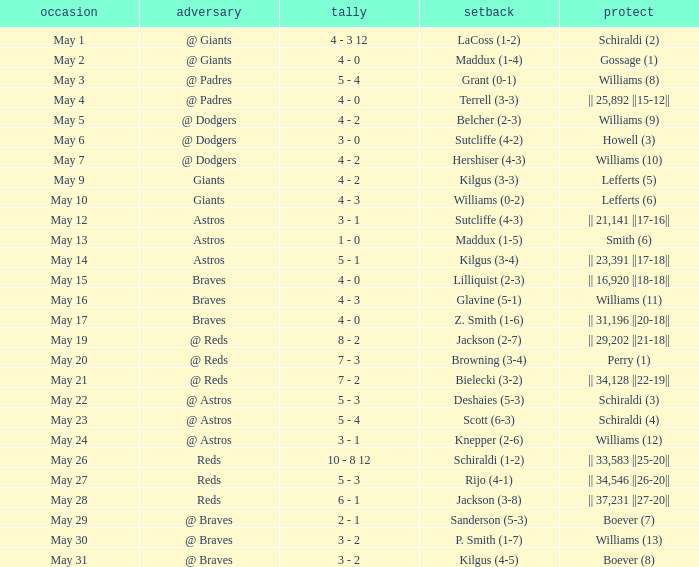Name the opponent for save of williams (9) @ Dodgers. 